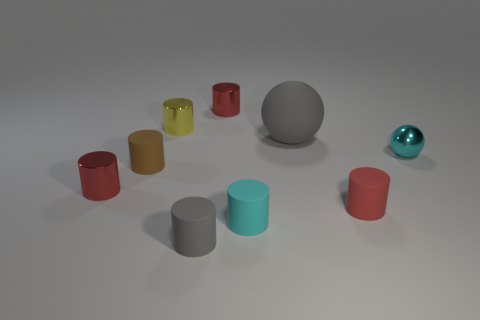Subtract all tiny red cylinders. How many cylinders are left? 4 Subtract all red cylinders. How many cylinders are left? 4 Subtract all cylinders. How many objects are left? 2 Subtract all cyan spheres. How many gray cylinders are left? 1 Add 5 matte cylinders. How many matte cylinders are left? 9 Add 1 red metal objects. How many red metal objects exist? 3 Add 1 brown balls. How many objects exist? 10 Subtract 0 gray cubes. How many objects are left? 9 Subtract 7 cylinders. How many cylinders are left? 0 Subtract all cyan cylinders. Subtract all gray cubes. How many cylinders are left? 6 